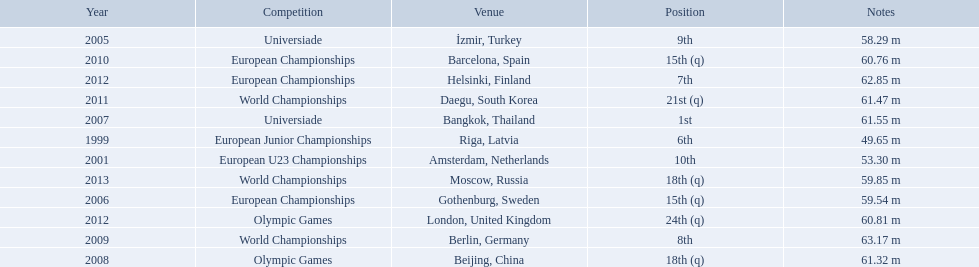What european junior championships? 6th. What waseuropean junior championships best result? 63.17 m. 